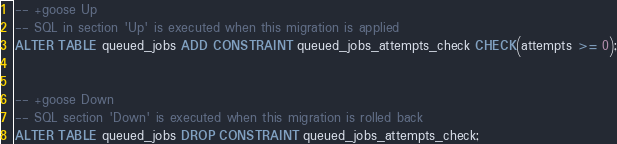Convert code to text. <code><loc_0><loc_0><loc_500><loc_500><_SQL_>-- +goose Up
-- SQL in section 'Up' is executed when this migration is applied
ALTER TABLE queued_jobs ADD CONSTRAINT queued_jobs_attempts_check CHECK(attempts >= 0);


-- +goose Down
-- SQL section 'Down' is executed when this migration is rolled back
ALTER TABLE queued_jobs DROP CONSTRAINT queued_jobs_attempts_check;
</code> 